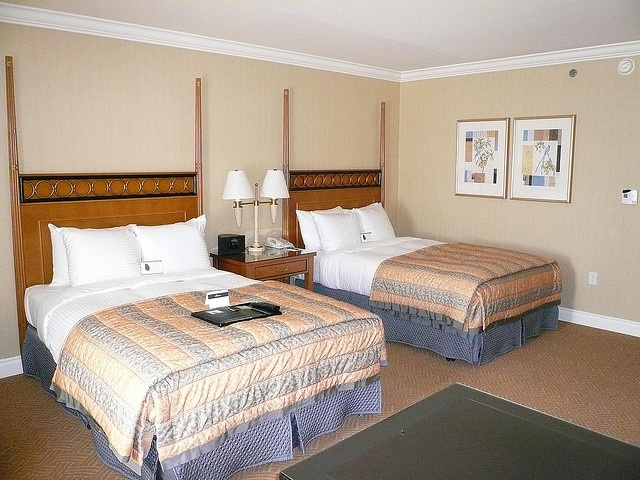Describe the objects in this image and their specific colors. I can see bed in gray, lightgray, darkgray, and tan tones, bed in gray, lightgray, and tan tones, laptop in gray, black, darkgray, and lightgray tones, and remote in gray and black tones in this image. 